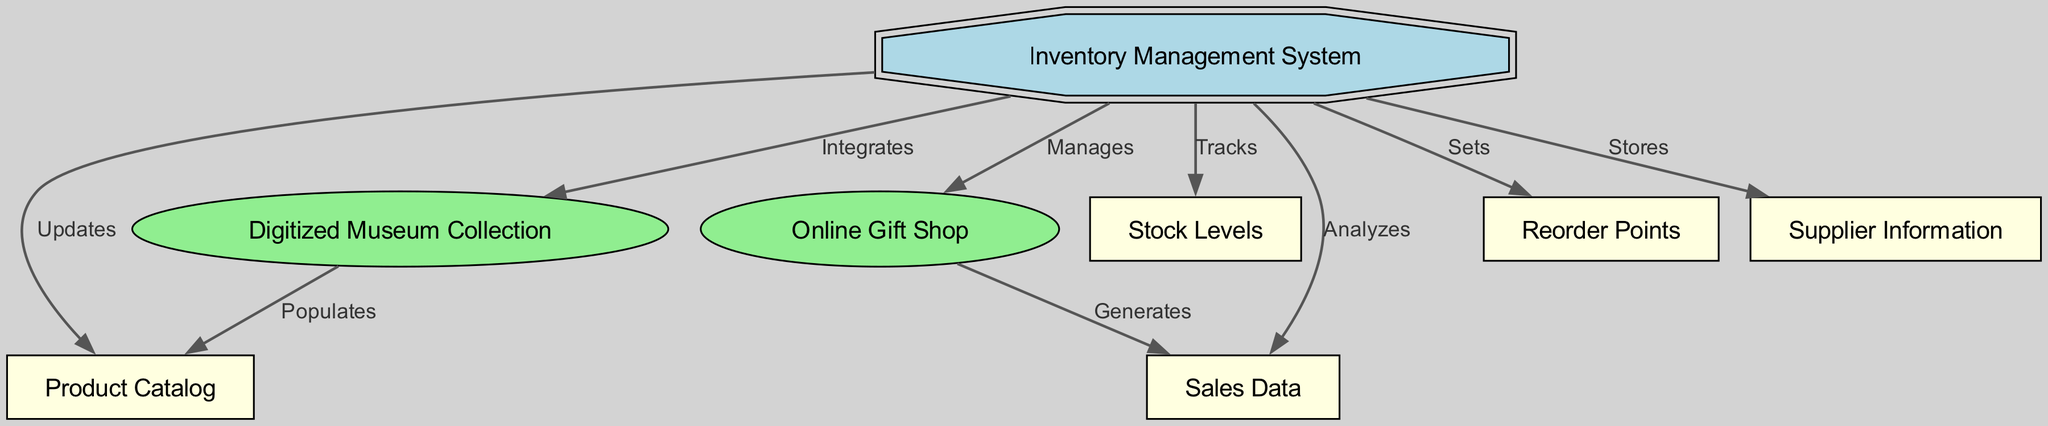What is the main component of the system? The main component depicted in the diagram is the "Inventory Management System," which is at the center, indicating its role in the overall structure.
Answer: Inventory Management System How many nodes are present in the diagram? The diagram includes a total of 7 nodes, which represent different components related to the inventory management system and its operations.
Answer: 7 What relationship does the inventory management system have with the online store? The inventory management system manages the online store, as indicated by the edge labeled "Manages" between the two nodes.
Answer: Manages Which component is integrated with the inventory management system? The "Digitized Museum Collection" is integrated with the inventory management system, as shown by the edge labeled "Integrates."
Answer: Digitized Museum Collection What does the inventory management system analyze? It analyzes "Sales Data," which is demonstrated by the edge between the two nodes labeled "Analyzes."
Answer: Sales Data How many different types of relationships are indicated in the diagram? There are 6 different types of relationships indicated between the nodes, showcasing various functions of the inventory system like tracking, updating, and generating.
Answer: 6 What does the digitized museum collection do for the product catalog? The digitized museum collection populates the product catalog, as featured by the edge labeled "Populates" between these nodes.
Answer: Populates What component is responsible for setting reorder points? The "Inventory Management System" is responsible for setting reorder points, indicated by the edge labeled "Sets" connecting them.
Answer: Sets What type of information does the inventory management system store? It stores "Supplier Information," as depicted in the relationship labeled "Stores" connecting these two nodes.
Answer: Supplier Information 